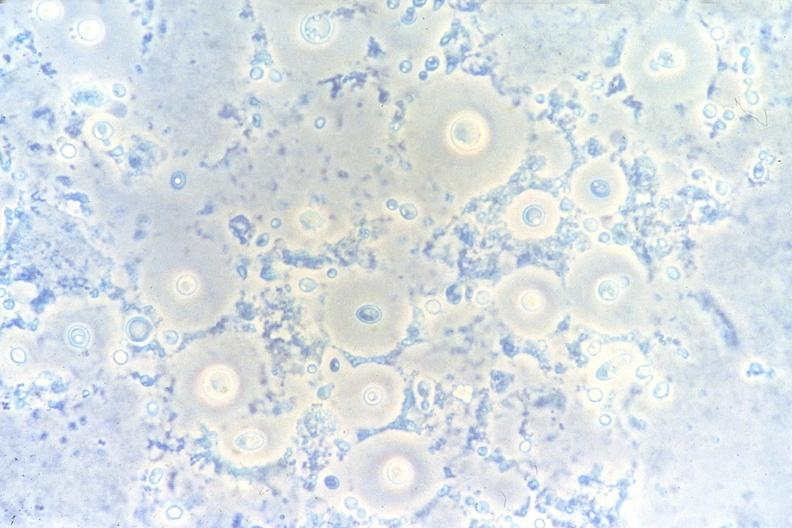s respiratory present?
Answer the question using a single word or phrase. Yes 